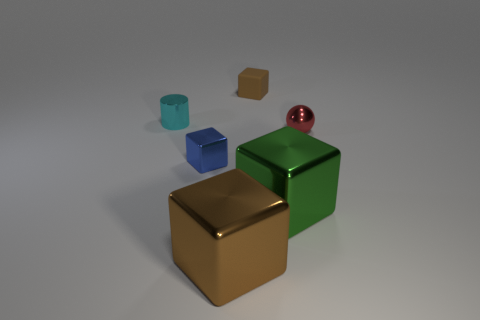How many other cubes have the same color as the small matte block?
Your answer should be very brief. 1. Do the large thing right of the tiny matte block and the large metal thing that is in front of the large green metallic object have the same shape?
Offer a very short reply. Yes. There is a large block that is to the left of the big cube that is on the right side of the big brown metal object in front of the tiny blue metallic cube; what is its color?
Give a very brief answer. Brown. What is the color of the shiny cube that is right of the big brown block?
Your answer should be compact. Green. What is the color of the metal ball that is the same size as the shiny cylinder?
Provide a succinct answer. Red. Is the brown metal cube the same size as the cyan thing?
Offer a terse response. No. There is a tiny cyan metal cylinder; how many big things are to the right of it?
Ensure brevity in your answer.  2. What number of things are large brown things in front of the blue shiny cube or big metallic blocks?
Keep it short and to the point. 2. Is the number of shiny objects behind the small shiny cube greater than the number of tiny metal blocks that are on the right side of the big green metallic object?
Keep it short and to the point. Yes. There is a metal block that is the same color as the matte thing; what size is it?
Keep it short and to the point. Large. 